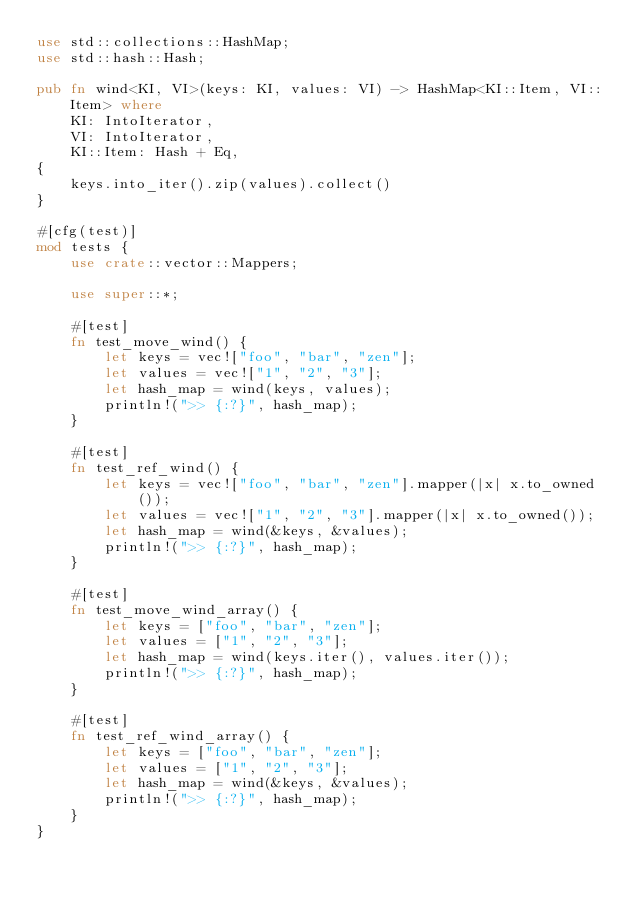Convert code to text. <code><loc_0><loc_0><loc_500><loc_500><_Rust_>use std::collections::HashMap;
use std::hash::Hash;

pub fn wind<KI, VI>(keys: KI, values: VI) -> HashMap<KI::Item, VI::Item> where
    KI: IntoIterator,
    VI: IntoIterator,
    KI::Item: Hash + Eq,
{
    keys.into_iter().zip(values).collect()
}

#[cfg(test)]
mod tests {
    use crate::vector::Mappers;

    use super::*;

    #[test]
    fn test_move_wind() {
        let keys = vec!["foo", "bar", "zen"];
        let values = vec!["1", "2", "3"];
        let hash_map = wind(keys, values);
        println!(">> {:?}", hash_map);
    }

    #[test]
    fn test_ref_wind() {
        let keys = vec!["foo", "bar", "zen"].mapper(|x| x.to_owned());
        let values = vec!["1", "2", "3"].mapper(|x| x.to_owned());
        let hash_map = wind(&keys, &values);
        println!(">> {:?}", hash_map);
    }

    #[test]
    fn test_move_wind_array() {
        let keys = ["foo", "bar", "zen"];
        let values = ["1", "2", "3"];
        let hash_map = wind(keys.iter(), values.iter());
        println!(">> {:?}", hash_map);
    }

    #[test]
    fn test_ref_wind_array() {
        let keys = ["foo", "bar", "zen"];
        let values = ["1", "2", "3"];
        let hash_map = wind(&keys, &values);
        println!(">> {:?}", hash_map);
    }
}
</code> 